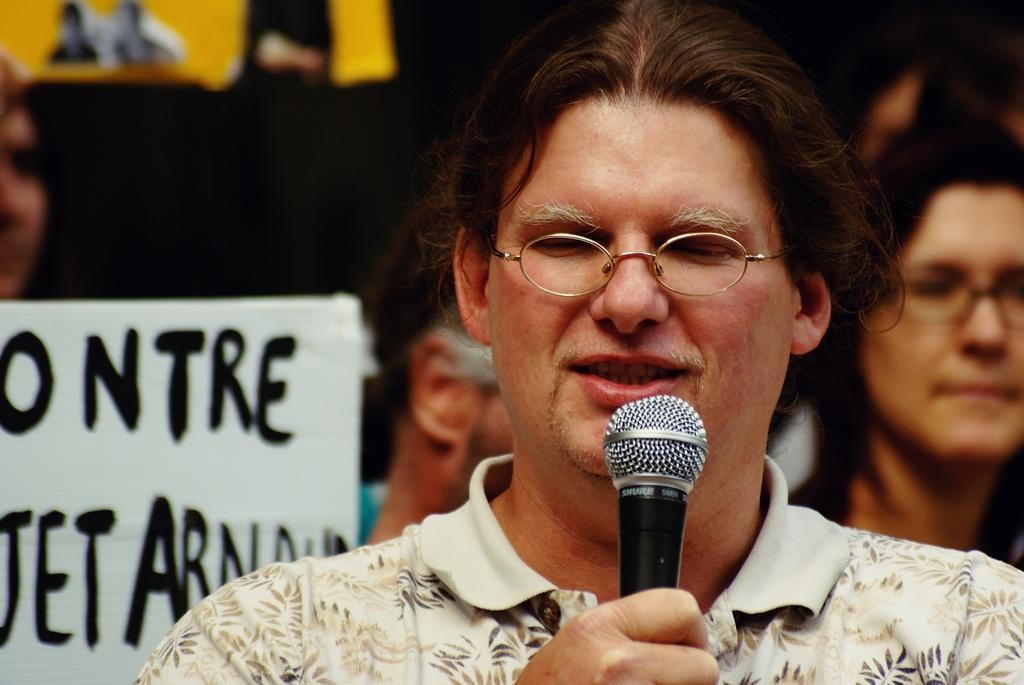In one or two sentences, can you explain what this image depicts? There is a person talking and he is holding a mic. Behind him some persons are there. And there is a banner over there. And this person is wearing a spectacle and t shirt. 